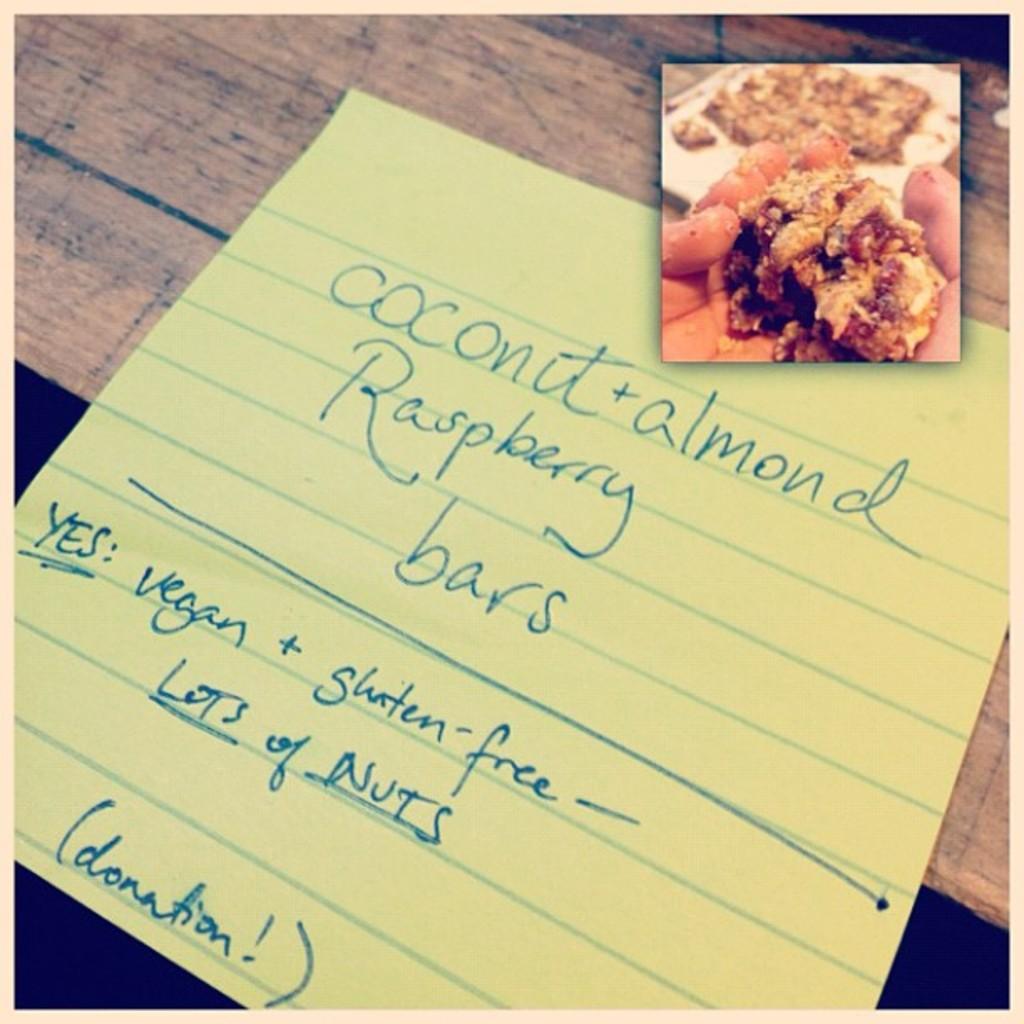What is the pastry in the picture called?
Your response must be concise. Coconut almond raspberry bars. Is this vegan?
Provide a succinct answer. Yes. 